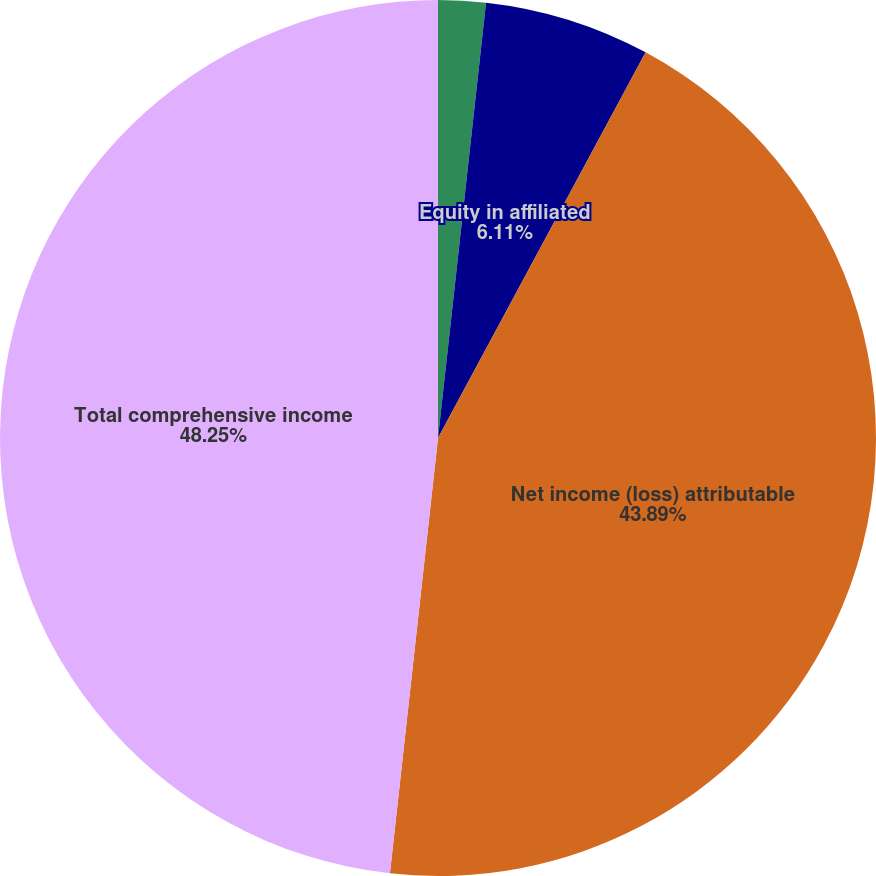<chart> <loc_0><loc_0><loc_500><loc_500><pie_chart><fcel>Interest expense net<fcel>Equity in affiliated<fcel>Net income (loss) attributable<fcel>Total comprehensive income<nl><fcel>1.75%<fcel>6.11%<fcel>43.89%<fcel>48.25%<nl></chart> 